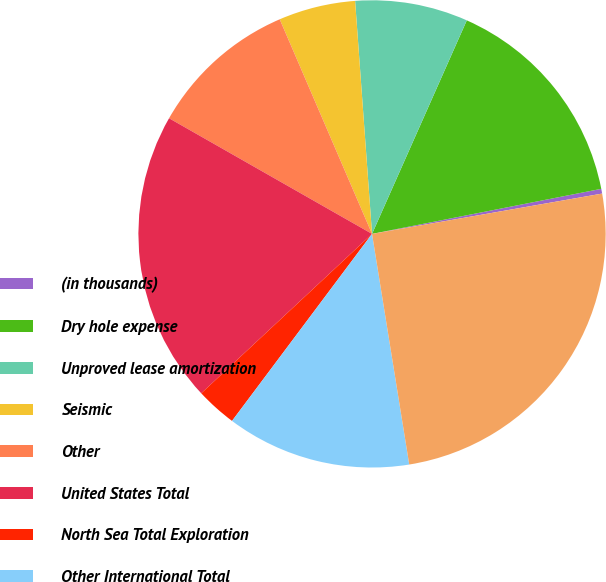Convert chart to OTSL. <chart><loc_0><loc_0><loc_500><loc_500><pie_chart><fcel>(in thousands)<fcel>Dry hole expense<fcel>Unproved lease amortization<fcel>Seismic<fcel>Other<fcel>United States Total<fcel>North Sea Total Exploration<fcel>Other International Total<fcel>Total Exploration Expense<nl><fcel>0.33%<fcel>15.26%<fcel>7.8%<fcel>5.31%<fcel>10.29%<fcel>20.19%<fcel>2.82%<fcel>12.77%<fcel>25.21%<nl></chart> 